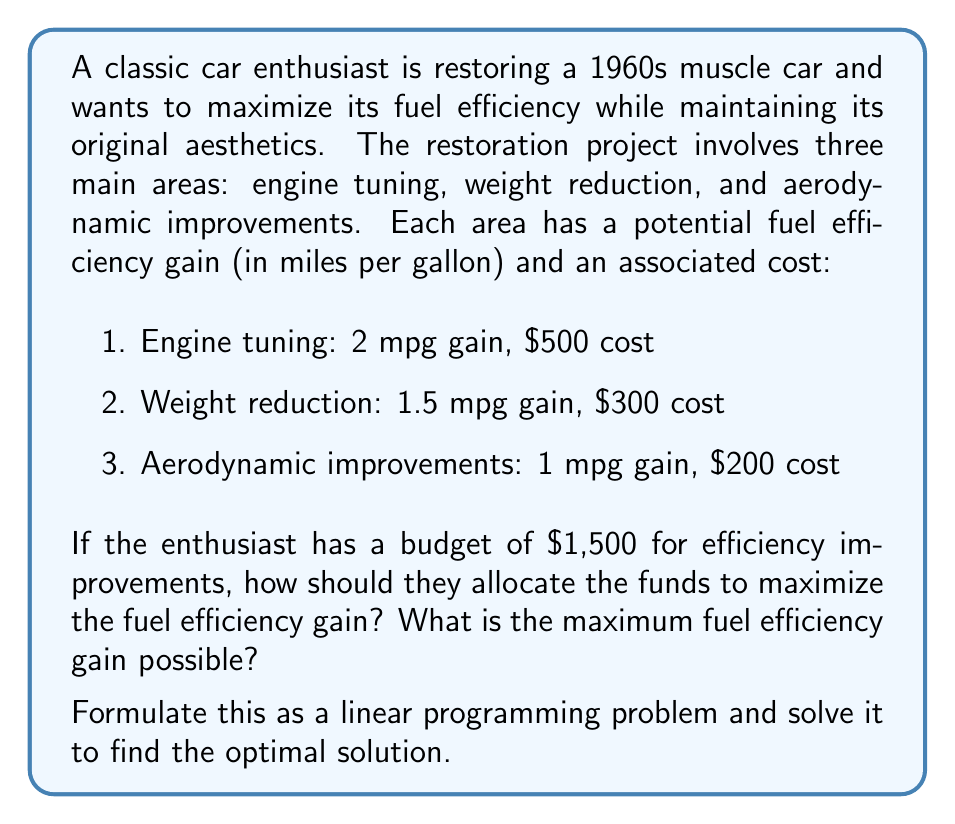Show me your answer to this math problem. Let's approach this problem step-by-step using linear programming:

1. Define variables:
   Let $x_1$, $x_2$, and $x_3$ be the number of units invested in engine tuning, weight reduction, and aerodynamic improvements, respectively.

2. Objective function:
   We want to maximize the total fuel efficiency gain:
   $$\text{Maximize } Z = 2x_1 + 1.5x_2 + x_3$$

3. Constraints:
   Budget constraint: $$500x_1 + 300x_2 + 200x_3 \leq 1500$$
   Non-negativity constraints: $$x_1, x_2, x_3 \geq 0$$

4. Since we're dealing with whole units of improvements, we need to add integer constraints:
   $$x_1, x_2, x_3 \text{ are integers}$$

5. Solving the problem:
   This is an integer linear programming problem. We can solve it using the branch and bound method or by examining all feasible integer solutions.

   Possible combinations within the budget:
   - 3 engine tuning units: 3 * 2 = 6 mpg gain
   - 5 weight reduction units: 5 * 1.5 = 7.5 mpg gain
   - 7 aerodynamic improvement units: 7 * 1 = 7 mpg gain
   - 2 engine tuning + 1 weight reduction + 1 aerodynamic: 2*2 + 1*1.5 + 1*1 = 5.5 mpg gain
   - 1 engine tuning + 3 weight reduction: 1*2 + 3*1.5 = 6.5 mpg gain
   - 1 engine tuning + 2 weight reduction + 2 aerodynamic: 1*2 + 2*1.5 + 2*1 = 6 mpg gain

6. The optimal solution is to invest in 5 units of weight reduction, which gives the maximum fuel efficiency gain of 7.5 mpg within the budget constraints.
Answer: The optimal solution is to invest in 5 units of weight reduction, resulting in a maximum fuel efficiency gain of 7.5 mpg. 